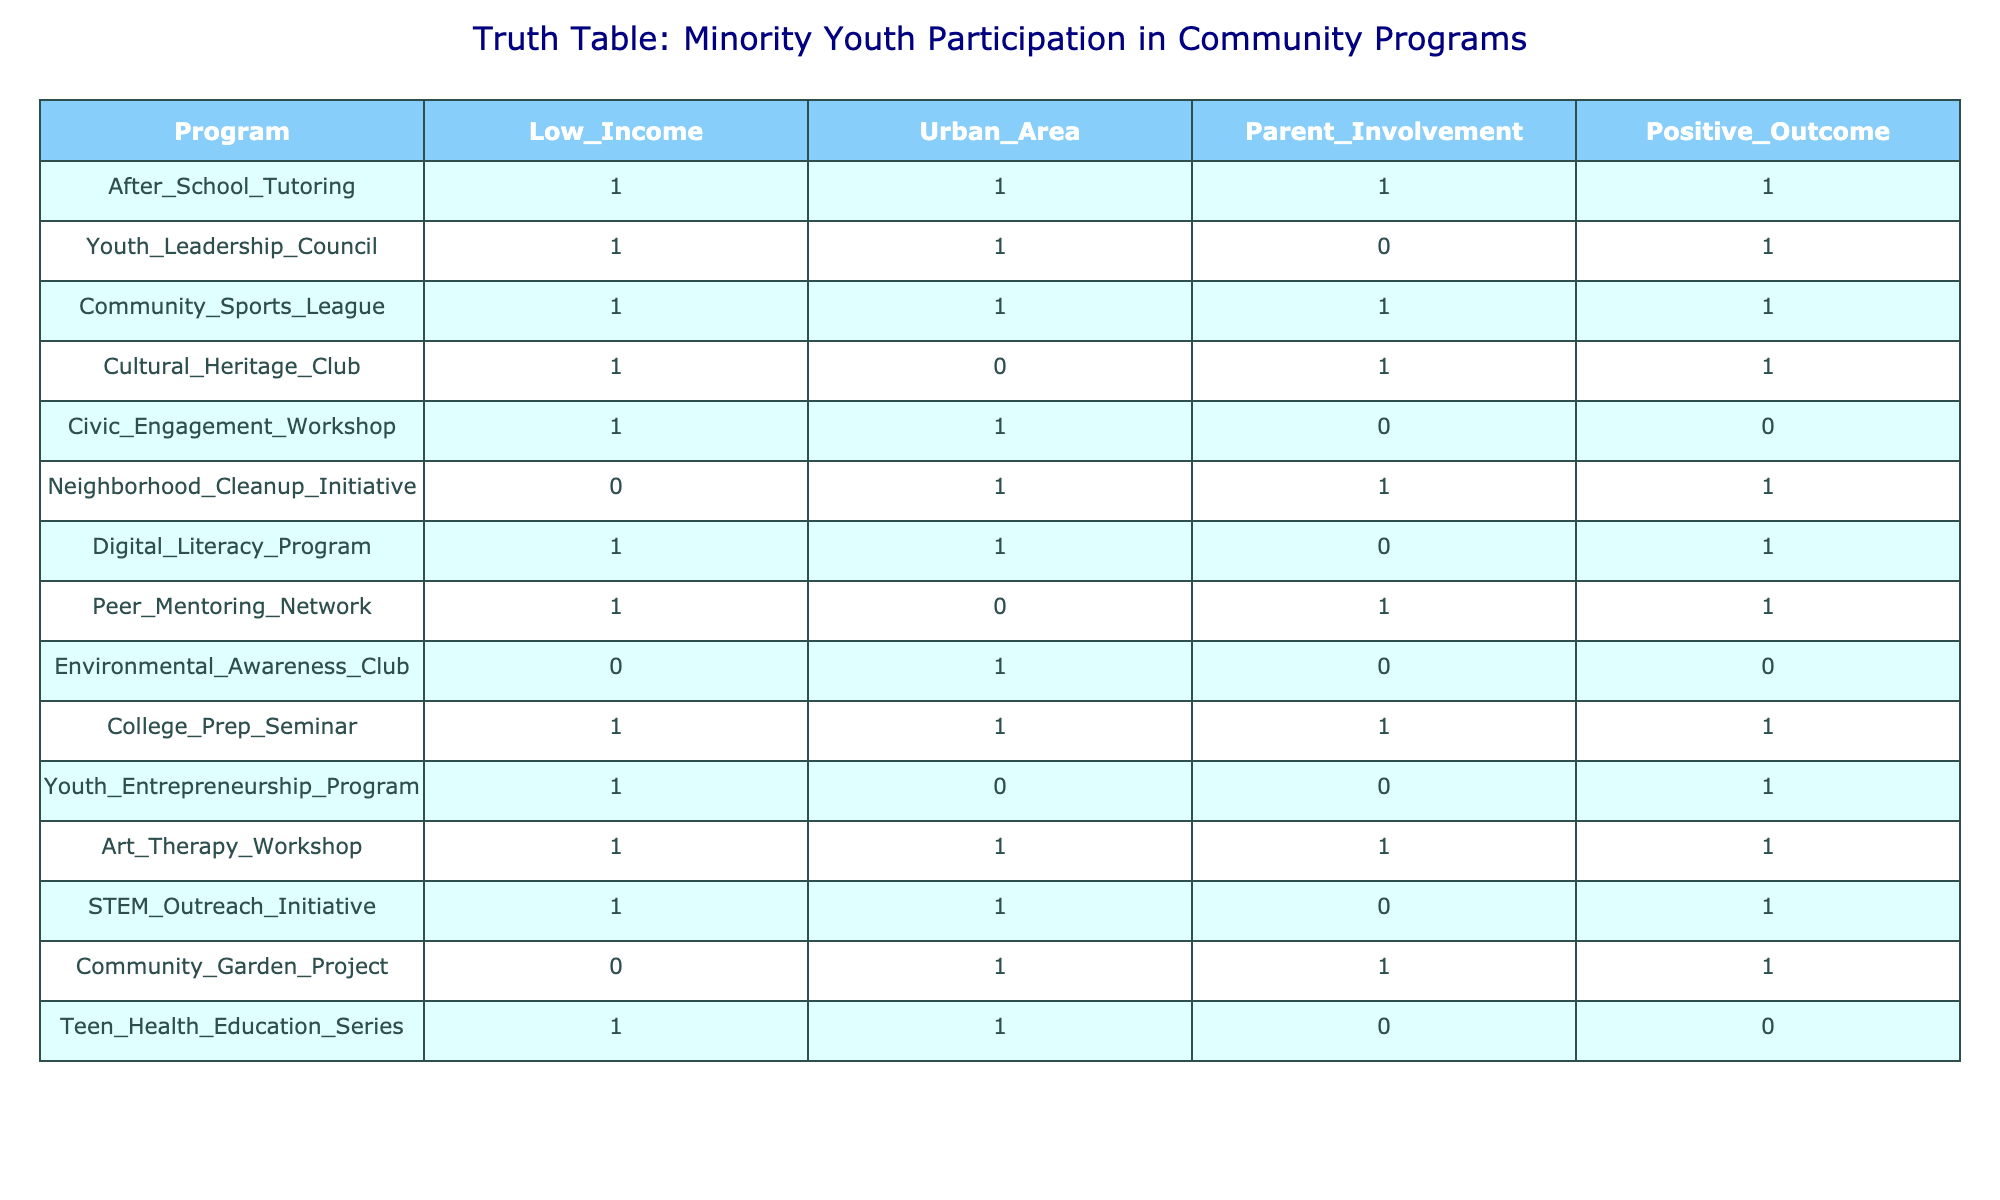What programs have a positive outcome when parent involvement is high? To answer this, we look at the column "Parent_Involvement" and filter the rows where its value is 1. Then, we check the corresponding values in the "Positive_Outcome" column. The programs that meet these criteria are: After School Tutoring, Community Sports League, Cultural Heritage Club, College Prep Seminar, Art Therapy Workshop.
Answer: After School Tutoring, Community Sports League, Cultural Heritage Club, College Prep Seminar, Art Therapy Workshop Is there any program that does not have parent involvement but still achieves a positive outcome? We check the "Parent_Involvement" column for rows with a value of 0 and look at the "Positive_Outcome" column. The only program that satisfies this is the Youth Entrepreneurship Program, which has a positive outcome despite lacking parent involvement.
Answer: Yes, the Youth Entrepreneurship Program What is the total number of programs conducted in urban areas that have a positive outcome? We filter the table for rows with "Urban_Area" equal to 1 and "Positive_Outcome" equals to 1. The programs that fit this criteria are After School Tutoring, Youth Leadership Council, Community Sports League, Cultural Heritage Club, College Prep Seminar, Art Therapy Workshop, and STEM Outreach Initiative. There are 7 of them in total.
Answer: 7 How many programs targeted at low-income youth did not have positive outcomes? We check the "Low_Income" column for value 1 and then look at the "Positive_Outcome" column for values of 0. The only program that meets this criteria is the Civic Engagement Workshop and the Teen Health Education Series. Thus, there are 2 programs that did not achieve positive outcomes.
Answer: 2 Are there any programs in urban areas with positive outcomes that do not include parent involvement? We examine rows where "Urban_Area" is 1, "Positive_Outcome" is 1, and "Parent_Involvement" is 0. The relevant programs are Youth Leadership Council and Digital Literacy Program. They are both located in urban areas and still yield positive outcomes without parent involvement.
Answer: Yes, Youth Leadership Council and Digital Literacy Program Which program has the highest number of criteria with a positive outcome based on the three factors provided? To find this, we will assign scores by counting how many of the three criteria ("Low_Income," "Urban_Area," "Parent_Involvement") are a value of 1 for each program. The program with all three criteria met is After School Tutoring, Community Sports League, College Prep Seminar, and Art Therapy Workshop which each scored 3.
Answer: After School Tutoring, Community Sports League, College Prep Seminar, Art Therapy Workshop What percentage of programs achieve positive outcomes out of the total? There are 14 total programs listed. The positive outcomes are found in 9 programs. So the calculation is (9/14) * 100 = 64.29%. This shows that approximately 64.29% of the programs successfully achieve positive outcomes.
Answer: 64.29% What is the relationship between being in an urban area and positive program outcomes? To analyze this, we compare the count of programs in urban areas (with value 1) that end with a positive outcome and those that don't. There are 8 out of 10 urban programs that have positive outcomes while 2 do not (Civic Engagement Workshop and Teen Health Education Series). This suggests a strong correlation between urbanity and program success.
Answer: Strong correlation; 8 out of 10 programs have positive outcomes Which program offers positive outcomes while only having involvement from low-income youth? We look at the "Low_Income" column where the value is 1 and check if the "Parent_Involvement" is also 0 to find programs yielding positive outcomes. The only relevant program in this case is the Youth Entrepreneurship Program.
Answer: Youth Entrepreneurship Program 